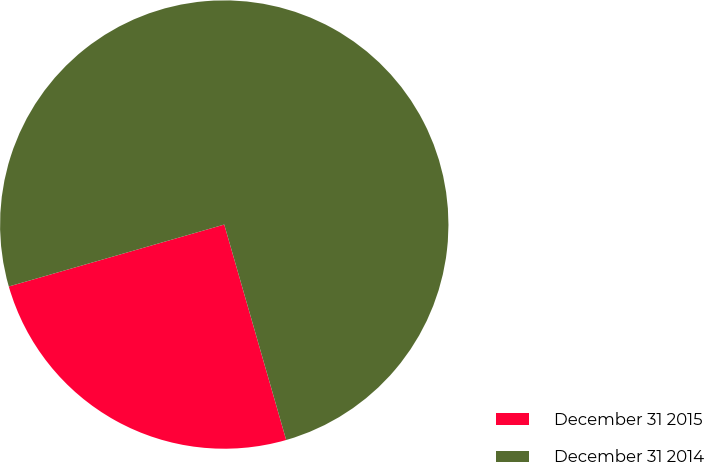Convert chart to OTSL. <chart><loc_0><loc_0><loc_500><loc_500><pie_chart><fcel>December 31 2015<fcel>December 31 2014<nl><fcel>25.0%<fcel>75.0%<nl></chart> 